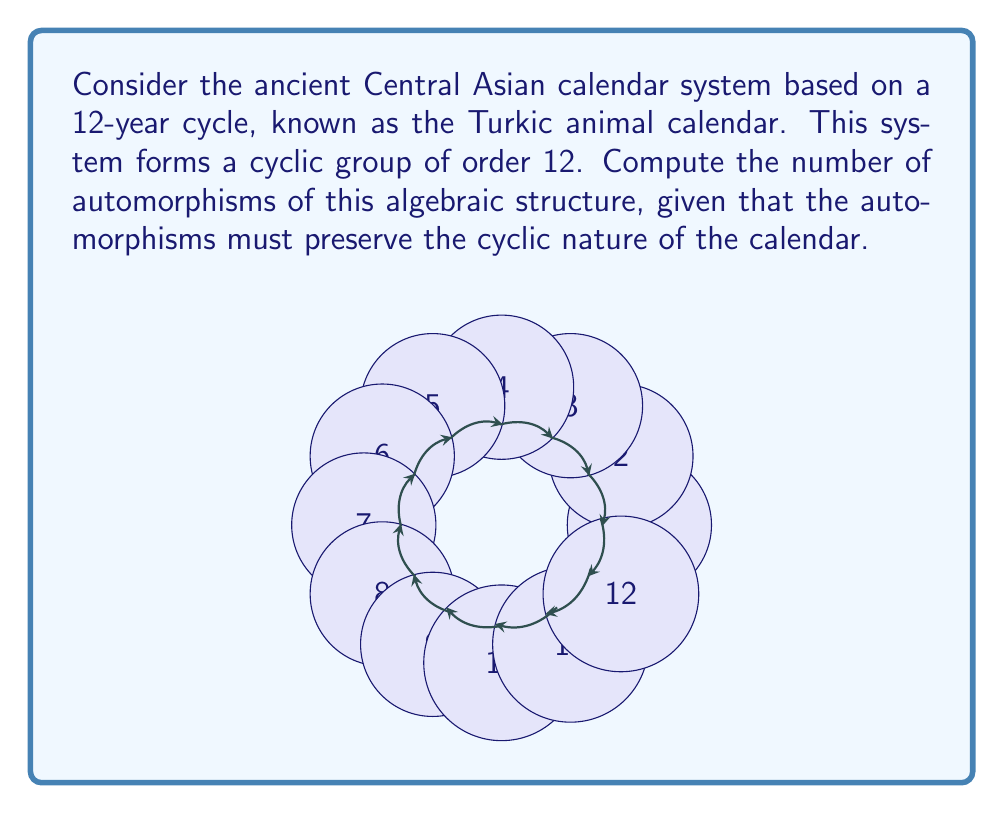Help me with this question. To solve this problem, we'll follow these steps:

1) First, recall that the automorphism group of a cyclic group of order n is isomorphic to the multiplicative group of units modulo n, denoted as $U(n)$.

2) In this case, n = 12, so we need to find $|U(12)|$.

3) To find $U(12)$, we need to count the number of integers from 1 to 11 that are coprime to 12.

4) The integers coprime to 12 are: 1, 5, 7, 11.

5) Therefore, $|U(12)| = 4$.

6) This means there are 4 automorphisms of the cyclic group of order 12.

7) These automorphisms correspond to the following mappings of the generator:
   $$\begin{aligned}
   \phi_1 &: x \mapsto x^1 = x \\
   \phi_5 &: x \mapsto x^5 \\
   \phi_7 &: x \mapsto x^7 \\
   \phi_{11} &: x \mapsto x^{11} = x^{-1}
   \end{aligned}$$

8) Each of these automorphisms preserves the cyclic structure of the calendar while permuting the elements in a way that maintains the group properties.
Answer: 4 